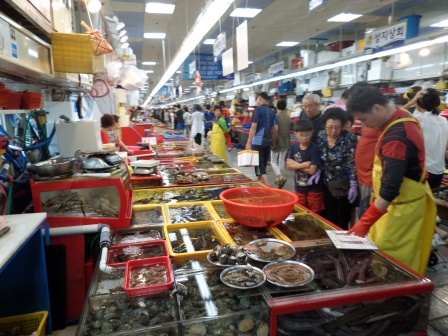Describe the atmosphere at the market. The atmosphere at the market is bustling and vibrant. The air is filled with the sounds of conversations and transactions, the occasional splash of water from the tanks, and the faint hum of refrigeration units. The lively interactions between vendors and customers add to the dynamic energy of the space. Brightly colored seafood and neatly arranged tanks contribute to the visually stimulating environment. The warm lighting from the hanging lights enhances this energetic scene, making it an inviting place for shoppers looking for fresh seafood. 